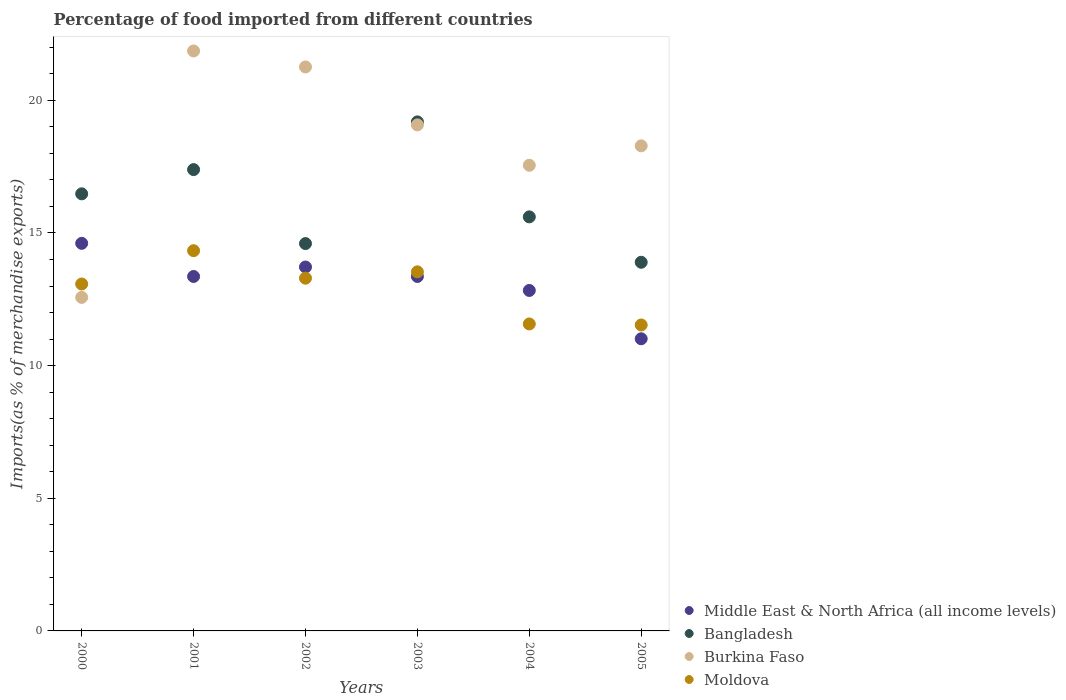What is the percentage of imports to different countries in Bangladesh in 2005?
Make the answer very short. 13.9. Across all years, what is the maximum percentage of imports to different countries in Burkina Faso?
Make the answer very short. 21.86. Across all years, what is the minimum percentage of imports to different countries in Bangladesh?
Ensure brevity in your answer.  13.9. In which year was the percentage of imports to different countries in Bangladesh minimum?
Ensure brevity in your answer.  2005. What is the total percentage of imports to different countries in Bangladesh in the graph?
Keep it short and to the point. 97.16. What is the difference between the percentage of imports to different countries in Moldova in 2000 and that in 2004?
Provide a short and direct response. 1.51. What is the difference between the percentage of imports to different countries in Bangladesh in 2004 and the percentage of imports to different countries in Moldova in 2003?
Provide a short and direct response. 2.07. What is the average percentage of imports to different countries in Middle East & North Africa (all income levels) per year?
Make the answer very short. 13.15. In the year 2004, what is the difference between the percentage of imports to different countries in Moldova and percentage of imports to different countries in Burkina Faso?
Make the answer very short. -5.98. In how many years, is the percentage of imports to different countries in Moldova greater than 12 %?
Provide a succinct answer. 4. What is the ratio of the percentage of imports to different countries in Burkina Faso in 2001 to that in 2003?
Make the answer very short. 1.15. Is the percentage of imports to different countries in Middle East & North Africa (all income levels) in 2003 less than that in 2004?
Keep it short and to the point. No. Is the difference between the percentage of imports to different countries in Moldova in 2004 and 2005 greater than the difference between the percentage of imports to different countries in Burkina Faso in 2004 and 2005?
Make the answer very short. Yes. What is the difference between the highest and the second highest percentage of imports to different countries in Moldova?
Offer a terse response. 0.8. What is the difference between the highest and the lowest percentage of imports to different countries in Middle East & North Africa (all income levels)?
Ensure brevity in your answer.  3.6. In how many years, is the percentage of imports to different countries in Moldova greater than the average percentage of imports to different countries in Moldova taken over all years?
Provide a succinct answer. 4. Does the percentage of imports to different countries in Middle East & North Africa (all income levels) monotonically increase over the years?
Provide a short and direct response. No. Is the percentage of imports to different countries in Middle East & North Africa (all income levels) strictly greater than the percentage of imports to different countries in Moldova over the years?
Make the answer very short. No. How many years are there in the graph?
Ensure brevity in your answer.  6. Are the values on the major ticks of Y-axis written in scientific E-notation?
Offer a terse response. No. Does the graph contain any zero values?
Provide a short and direct response. No. Where does the legend appear in the graph?
Offer a terse response. Bottom right. How many legend labels are there?
Your response must be concise. 4. How are the legend labels stacked?
Ensure brevity in your answer.  Vertical. What is the title of the graph?
Offer a terse response. Percentage of food imported from different countries. What is the label or title of the Y-axis?
Give a very brief answer. Imports(as % of merchandise exports). What is the Imports(as % of merchandise exports) of Middle East & North Africa (all income levels) in 2000?
Make the answer very short. 14.61. What is the Imports(as % of merchandise exports) of Bangladesh in 2000?
Make the answer very short. 16.48. What is the Imports(as % of merchandise exports) of Burkina Faso in 2000?
Give a very brief answer. 12.57. What is the Imports(as % of merchandise exports) in Moldova in 2000?
Give a very brief answer. 13.08. What is the Imports(as % of merchandise exports) of Middle East & North Africa (all income levels) in 2001?
Your answer should be very brief. 13.36. What is the Imports(as % of merchandise exports) in Bangladesh in 2001?
Your response must be concise. 17.39. What is the Imports(as % of merchandise exports) of Burkina Faso in 2001?
Offer a very short reply. 21.86. What is the Imports(as % of merchandise exports) in Moldova in 2001?
Offer a terse response. 14.33. What is the Imports(as % of merchandise exports) in Middle East & North Africa (all income levels) in 2002?
Your answer should be very brief. 13.72. What is the Imports(as % of merchandise exports) in Bangladesh in 2002?
Keep it short and to the point. 14.6. What is the Imports(as % of merchandise exports) in Burkina Faso in 2002?
Offer a very short reply. 21.26. What is the Imports(as % of merchandise exports) in Moldova in 2002?
Offer a terse response. 13.3. What is the Imports(as % of merchandise exports) of Middle East & North Africa (all income levels) in 2003?
Make the answer very short. 13.36. What is the Imports(as % of merchandise exports) of Bangladesh in 2003?
Your answer should be compact. 19.19. What is the Imports(as % of merchandise exports) of Burkina Faso in 2003?
Keep it short and to the point. 19.07. What is the Imports(as % of merchandise exports) in Moldova in 2003?
Your answer should be very brief. 13.54. What is the Imports(as % of merchandise exports) in Middle East & North Africa (all income levels) in 2004?
Provide a short and direct response. 12.83. What is the Imports(as % of merchandise exports) of Bangladesh in 2004?
Provide a short and direct response. 15.61. What is the Imports(as % of merchandise exports) of Burkina Faso in 2004?
Offer a very short reply. 17.55. What is the Imports(as % of merchandise exports) of Moldova in 2004?
Keep it short and to the point. 11.57. What is the Imports(as % of merchandise exports) in Middle East & North Africa (all income levels) in 2005?
Keep it short and to the point. 11.01. What is the Imports(as % of merchandise exports) of Bangladesh in 2005?
Offer a very short reply. 13.9. What is the Imports(as % of merchandise exports) of Burkina Faso in 2005?
Make the answer very short. 18.28. What is the Imports(as % of merchandise exports) in Moldova in 2005?
Keep it short and to the point. 11.53. Across all years, what is the maximum Imports(as % of merchandise exports) in Middle East & North Africa (all income levels)?
Make the answer very short. 14.61. Across all years, what is the maximum Imports(as % of merchandise exports) in Bangladesh?
Offer a terse response. 19.19. Across all years, what is the maximum Imports(as % of merchandise exports) in Burkina Faso?
Provide a succinct answer. 21.86. Across all years, what is the maximum Imports(as % of merchandise exports) of Moldova?
Provide a succinct answer. 14.33. Across all years, what is the minimum Imports(as % of merchandise exports) of Middle East & North Africa (all income levels)?
Offer a terse response. 11.01. Across all years, what is the minimum Imports(as % of merchandise exports) in Bangladesh?
Offer a very short reply. 13.9. Across all years, what is the minimum Imports(as % of merchandise exports) in Burkina Faso?
Offer a very short reply. 12.57. Across all years, what is the minimum Imports(as % of merchandise exports) in Moldova?
Keep it short and to the point. 11.53. What is the total Imports(as % of merchandise exports) of Middle East & North Africa (all income levels) in the graph?
Offer a very short reply. 78.9. What is the total Imports(as % of merchandise exports) of Bangladesh in the graph?
Provide a short and direct response. 97.16. What is the total Imports(as % of merchandise exports) of Burkina Faso in the graph?
Give a very brief answer. 110.6. What is the total Imports(as % of merchandise exports) of Moldova in the graph?
Provide a short and direct response. 77.34. What is the difference between the Imports(as % of merchandise exports) of Middle East & North Africa (all income levels) in 2000 and that in 2001?
Provide a succinct answer. 1.25. What is the difference between the Imports(as % of merchandise exports) of Bangladesh in 2000 and that in 2001?
Keep it short and to the point. -0.91. What is the difference between the Imports(as % of merchandise exports) in Burkina Faso in 2000 and that in 2001?
Provide a succinct answer. -9.29. What is the difference between the Imports(as % of merchandise exports) in Moldova in 2000 and that in 2001?
Provide a short and direct response. -1.26. What is the difference between the Imports(as % of merchandise exports) of Middle East & North Africa (all income levels) in 2000 and that in 2002?
Ensure brevity in your answer.  0.89. What is the difference between the Imports(as % of merchandise exports) in Bangladesh in 2000 and that in 2002?
Offer a very short reply. 1.87. What is the difference between the Imports(as % of merchandise exports) in Burkina Faso in 2000 and that in 2002?
Your answer should be very brief. -8.69. What is the difference between the Imports(as % of merchandise exports) in Moldova in 2000 and that in 2002?
Give a very brief answer. -0.22. What is the difference between the Imports(as % of merchandise exports) of Middle East & North Africa (all income levels) in 2000 and that in 2003?
Offer a very short reply. 1.25. What is the difference between the Imports(as % of merchandise exports) in Bangladesh in 2000 and that in 2003?
Keep it short and to the point. -2.71. What is the difference between the Imports(as % of merchandise exports) in Burkina Faso in 2000 and that in 2003?
Your answer should be compact. -6.5. What is the difference between the Imports(as % of merchandise exports) in Moldova in 2000 and that in 2003?
Offer a terse response. -0.46. What is the difference between the Imports(as % of merchandise exports) of Middle East & North Africa (all income levels) in 2000 and that in 2004?
Provide a short and direct response. 1.78. What is the difference between the Imports(as % of merchandise exports) of Bangladesh in 2000 and that in 2004?
Offer a very short reply. 0.87. What is the difference between the Imports(as % of merchandise exports) in Burkina Faso in 2000 and that in 2004?
Provide a short and direct response. -4.98. What is the difference between the Imports(as % of merchandise exports) in Moldova in 2000 and that in 2004?
Provide a short and direct response. 1.51. What is the difference between the Imports(as % of merchandise exports) in Middle East & North Africa (all income levels) in 2000 and that in 2005?
Provide a succinct answer. 3.6. What is the difference between the Imports(as % of merchandise exports) in Bangladesh in 2000 and that in 2005?
Your answer should be very brief. 2.58. What is the difference between the Imports(as % of merchandise exports) in Burkina Faso in 2000 and that in 2005?
Make the answer very short. -5.71. What is the difference between the Imports(as % of merchandise exports) of Moldova in 2000 and that in 2005?
Offer a terse response. 1.54. What is the difference between the Imports(as % of merchandise exports) of Middle East & North Africa (all income levels) in 2001 and that in 2002?
Offer a very short reply. -0.36. What is the difference between the Imports(as % of merchandise exports) in Bangladesh in 2001 and that in 2002?
Give a very brief answer. 2.79. What is the difference between the Imports(as % of merchandise exports) of Burkina Faso in 2001 and that in 2002?
Offer a very short reply. 0.6. What is the difference between the Imports(as % of merchandise exports) of Moldova in 2001 and that in 2002?
Provide a succinct answer. 1.04. What is the difference between the Imports(as % of merchandise exports) of Middle East & North Africa (all income levels) in 2001 and that in 2003?
Make the answer very short. 0. What is the difference between the Imports(as % of merchandise exports) in Bangladesh in 2001 and that in 2003?
Offer a terse response. -1.8. What is the difference between the Imports(as % of merchandise exports) of Burkina Faso in 2001 and that in 2003?
Keep it short and to the point. 2.79. What is the difference between the Imports(as % of merchandise exports) of Moldova in 2001 and that in 2003?
Your answer should be compact. 0.8. What is the difference between the Imports(as % of merchandise exports) in Middle East & North Africa (all income levels) in 2001 and that in 2004?
Provide a succinct answer. 0.53. What is the difference between the Imports(as % of merchandise exports) in Bangladesh in 2001 and that in 2004?
Keep it short and to the point. 1.78. What is the difference between the Imports(as % of merchandise exports) of Burkina Faso in 2001 and that in 2004?
Keep it short and to the point. 4.31. What is the difference between the Imports(as % of merchandise exports) in Moldova in 2001 and that in 2004?
Ensure brevity in your answer.  2.76. What is the difference between the Imports(as % of merchandise exports) in Middle East & North Africa (all income levels) in 2001 and that in 2005?
Make the answer very short. 2.35. What is the difference between the Imports(as % of merchandise exports) in Bangladesh in 2001 and that in 2005?
Give a very brief answer. 3.49. What is the difference between the Imports(as % of merchandise exports) of Burkina Faso in 2001 and that in 2005?
Make the answer very short. 3.58. What is the difference between the Imports(as % of merchandise exports) of Moldova in 2001 and that in 2005?
Offer a terse response. 2.8. What is the difference between the Imports(as % of merchandise exports) in Middle East & North Africa (all income levels) in 2002 and that in 2003?
Offer a very short reply. 0.36. What is the difference between the Imports(as % of merchandise exports) of Bangladesh in 2002 and that in 2003?
Your answer should be compact. -4.59. What is the difference between the Imports(as % of merchandise exports) of Burkina Faso in 2002 and that in 2003?
Offer a very short reply. 2.18. What is the difference between the Imports(as % of merchandise exports) in Moldova in 2002 and that in 2003?
Give a very brief answer. -0.24. What is the difference between the Imports(as % of merchandise exports) in Middle East & North Africa (all income levels) in 2002 and that in 2004?
Offer a very short reply. 0.88. What is the difference between the Imports(as % of merchandise exports) in Bangladesh in 2002 and that in 2004?
Your answer should be compact. -1.01. What is the difference between the Imports(as % of merchandise exports) in Burkina Faso in 2002 and that in 2004?
Make the answer very short. 3.71. What is the difference between the Imports(as % of merchandise exports) of Moldova in 2002 and that in 2004?
Provide a succinct answer. 1.73. What is the difference between the Imports(as % of merchandise exports) in Middle East & North Africa (all income levels) in 2002 and that in 2005?
Your answer should be very brief. 2.7. What is the difference between the Imports(as % of merchandise exports) in Bangladesh in 2002 and that in 2005?
Ensure brevity in your answer.  0.7. What is the difference between the Imports(as % of merchandise exports) in Burkina Faso in 2002 and that in 2005?
Your response must be concise. 2.97. What is the difference between the Imports(as % of merchandise exports) in Moldova in 2002 and that in 2005?
Give a very brief answer. 1.76. What is the difference between the Imports(as % of merchandise exports) in Middle East & North Africa (all income levels) in 2003 and that in 2004?
Offer a very short reply. 0.53. What is the difference between the Imports(as % of merchandise exports) of Bangladesh in 2003 and that in 2004?
Your answer should be compact. 3.58. What is the difference between the Imports(as % of merchandise exports) in Burkina Faso in 2003 and that in 2004?
Your answer should be very brief. 1.52. What is the difference between the Imports(as % of merchandise exports) of Moldova in 2003 and that in 2004?
Your response must be concise. 1.96. What is the difference between the Imports(as % of merchandise exports) in Middle East & North Africa (all income levels) in 2003 and that in 2005?
Offer a terse response. 2.35. What is the difference between the Imports(as % of merchandise exports) in Bangladesh in 2003 and that in 2005?
Make the answer very short. 5.29. What is the difference between the Imports(as % of merchandise exports) of Burkina Faso in 2003 and that in 2005?
Offer a terse response. 0.79. What is the difference between the Imports(as % of merchandise exports) of Moldova in 2003 and that in 2005?
Provide a short and direct response. 2. What is the difference between the Imports(as % of merchandise exports) in Middle East & North Africa (all income levels) in 2004 and that in 2005?
Provide a short and direct response. 1.82. What is the difference between the Imports(as % of merchandise exports) of Bangladesh in 2004 and that in 2005?
Offer a terse response. 1.71. What is the difference between the Imports(as % of merchandise exports) of Burkina Faso in 2004 and that in 2005?
Ensure brevity in your answer.  -0.73. What is the difference between the Imports(as % of merchandise exports) of Moldova in 2004 and that in 2005?
Your response must be concise. 0.04. What is the difference between the Imports(as % of merchandise exports) of Middle East & North Africa (all income levels) in 2000 and the Imports(as % of merchandise exports) of Bangladesh in 2001?
Your response must be concise. -2.78. What is the difference between the Imports(as % of merchandise exports) of Middle East & North Africa (all income levels) in 2000 and the Imports(as % of merchandise exports) of Burkina Faso in 2001?
Your response must be concise. -7.25. What is the difference between the Imports(as % of merchandise exports) of Middle East & North Africa (all income levels) in 2000 and the Imports(as % of merchandise exports) of Moldova in 2001?
Ensure brevity in your answer.  0.28. What is the difference between the Imports(as % of merchandise exports) in Bangladesh in 2000 and the Imports(as % of merchandise exports) in Burkina Faso in 2001?
Your response must be concise. -5.39. What is the difference between the Imports(as % of merchandise exports) of Bangladesh in 2000 and the Imports(as % of merchandise exports) of Moldova in 2001?
Make the answer very short. 2.14. What is the difference between the Imports(as % of merchandise exports) of Burkina Faso in 2000 and the Imports(as % of merchandise exports) of Moldova in 2001?
Provide a short and direct response. -1.76. What is the difference between the Imports(as % of merchandise exports) of Middle East & North Africa (all income levels) in 2000 and the Imports(as % of merchandise exports) of Bangladesh in 2002?
Offer a very short reply. 0.01. What is the difference between the Imports(as % of merchandise exports) of Middle East & North Africa (all income levels) in 2000 and the Imports(as % of merchandise exports) of Burkina Faso in 2002?
Offer a very short reply. -6.65. What is the difference between the Imports(as % of merchandise exports) in Middle East & North Africa (all income levels) in 2000 and the Imports(as % of merchandise exports) in Moldova in 2002?
Ensure brevity in your answer.  1.31. What is the difference between the Imports(as % of merchandise exports) in Bangladesh in 2000 and the Imports(as % of merchandise exports) in Burkina Faso in 2002?
Your answer should be compact. -4.78. What is the difference between the Imports(as % of merchandise exports) of Bangladesh in 2000 and the Imports(as % of merchandise exports) of Moldova in 2002?
Your answer should be very brief. 3.18. What is the difference between the Imports(as % of merchandise exports) in Burkina Faso in 2000 and the Imports(as % of merchandise exports) in Moldova in 2002?
Provide a succinct answer. -0.72. What is the difference between the Imports(as % of merchandise exports) in Middle East & North Africa (all income levels) in 2000 and the Imports(as % of merchandise exports) in Bangladesh in 2003?
Provide a short and direct response. -4.58. What is the difference between the Imports(as % of merchandise exports) in Middle East & North Africa (all income levels) in 2000 and the Imports(as % of merchandise exports) in Burkina Faso in 2003?
Provide a succinct answer. -4.46. What is the difference between the Imports(as % of merchandise exports) of Middle East & North Africa (all income levels) in 2000 and the Imports(as % of merchandise exports) of Moldova in 2003?
Your answer should be compact. 1.07. What is the difference between the Imports(as % of merchandise exports) of Bangladesh in 2000 and the Imports(as % of merchandise exports) of Burkina Faso in 2003?
Your answer should be very brief. -2.6. What is the difference between the Imports(as % of merchandise exports) in Bangladesh in 2000 and the Imports(as % of merchandise exports) in Moldova in 2003?
Your answer should be compact. 2.94. What is the difference between the Imports(as % of merchandise exports) of Burkina Faso in 2000 and the Imports(as % of merchandise exports) of Moldova in 2003?
Make the answer very short. -0.96. What is the difference between the Imports(as % of merchandise exports) in Middle East & North Africa (all income levels) in 2000 and the Imports(as % of merchandise exports) in Bangladesh in 2004?
Keep it short and to the point. -1. What is the difference between the Imports(as % of merchandise exports) in Middle East & North Africa (all income levels) in 2000 and the Imports(as % of merchandise exports) in Burkina Faso in 2004?
Make the answer very short. -2.94. What is the difference between the Imports(as % of merchandise exports) in Middle East & North Africa (all income levels) in 2000 and the Imports(as % of merchandise exports) in Moldova in 2004?
Give a very brief answer. 3.04. What is the difference between the Imports(as % of merchandise exports) in Bangladesh in 2000 and the Imports(as % of merchandise exports) in Burkina Faso in 2004?
Your answer should be very brief. -1.08. What is the difference between the Imports(as % of merchandise exports) of Bangladesh in 2000 and the Imports(as % of merchandise exports) of Moldova in 2004?
Offer a very short reply. 4.91. What is the difference between the Imports(as % of merchandise exports) in Burkina Faso in 2000 and the Imports(as % of merchandise exports) in Moldova in 2004?
Your answer should be very brief. 1. What is the difference between the Imports(as % of merchandise exports) of Middle East & North Africa (all income levels) in 2000 and the Imports(as % of merchandise exports) of Bangladesh in 2005?
Offer a terse response. 0.71. What is the difference between the Imports(as % of merchandise exports) in Middle East & North Africa (all income levels) in 2000 and the Imports(as % of merchandise exports) in Burkina Faso in 2005?
Keep it short and to the point. -3.67. What is the difference between the Imports(as % of merchandise exports) of Middle East & North Africa (all income levels) in 2000 and the Imports(as % of merchandise exports) of Moldova in 2005?
Your answer should be very brief. 3.08. What is the difference between the Imports(as % of merchandise exports) in Bangladesh in 2000 and the Imports(as % of merchandise exports) in Burkina Faso in 2005?
Offer a very short reply. -1.81. What is the difference between the Imports(as % of merchandise exports) in Bangladesh in 2000 and the Imports(as % of merchandise exports) in Moldova in 2005?
Your answer should be compact. 4.94. What is the difference between the Imports(as % of merchandise exports) in Burkina Faso in 2000 and the Imports(as % of merchandise exports) in Moldova in 2005?
Provide a succinct answer. 1.04. What is the difference between the Imports(as % of merchandise exports) of Middle East & North Africa (all income levels) in 2001 and the Imports(as % of merchandise exports) of Bangladesh in 2002?
Ensure brevity in your answer.  -1.24. What is the difference between the Imports(as % of merchandise exports) of Middle East & North Africa (all income levels) in 2001 and the Imports(as % of merchandise exports) of Burkina Faso in 2002?
Ensure brevity in your answer.  -7.9. What is the difference between the Imports(as % of merchandise exports) in Middle East & North Africa (all income levels) in 2001 and the Imports(as % of merchandise exports) in Moldova in 2002?
Make the answer very short. 0.06. What is the difference between the Imports(as % of merchandise exports) in Bangladesh in 2001 and the Imports(as % of merchandise exports) in Burkina Faso in 2002?
Your answer should be very brief. -3.87. What is the difference between the Imports(as % of merchandise exports) in Bangladesh in 2001 and the Imports(as % of merchandise exports) in Moldova in 2002?
Offer a very short reply. 4.09. What is the difference between the Imports(as % of merchandise exports) of Burkina Faso in 2001 and the Imports(as % of merchandise exports) of Moldova in 2002?
Ensure brevity in your answer.  8.56. What is the difference between the Imports(as % of merchandise exports) of Middle East & North Africa (all income levels) in 2001 and the Imports(as % of merchandise exports) of Bangladesh in 2003?
Your answer should be very brief. -5.83. What is the difference between the Imports(as % of merchandise exports) of Middle East & North Africa (all income levels) in 2001 and the Imports(as % of merchandise exports) of Burkina Faso in 2003?
Keep it short and to the point. -5.71. What is the difference between the Imports(as % of merchandise exports) of Middle East & North Africa (all income levels) in 2001 and the Imports(as % of merchandise exports) of Moldova in 2003?
Offer a very short reply. -0.17. What is the difference between the Imports(as % of merchandise exports) in Bangladesh in 2001 and the Imports(as % of merchandise exports) in Burkina Faso in 2003?
Keep it short and to the point. -1.69. What is the difference between the Imports(as % of merchandise exports) of Bangladesh in 2001 and the Imports(as % of merchandise exports) of Moldova in 2003?
Ensure brevity in your answer.  3.85. What is the difference between the Imports(as % of merchandise exports) of Burkina Faso in 2001 and the Imports(as % of merchandise exports) of Moldova in 2003?
Make the answer very short. 8.33. What is the difference between the Imports(as % of merchandise exports) in Middle East & North Africa (all income levels) in 2001 and the Imports(as % of merchandise exports) in Bangladesh in 2004?
Make the answer very short. -2.25. What is the difference between the Imports(as % of merchandise exports) of Middle East & North Africa (all income levels) in 2001 and the Imports(as % of merchandise exports) of Burkina Faso in 2004?
Ensure brevity in your answer.  -4.19. What is the difference between the Imports(as % of merchandise exports) in Middle East & North Africa (all income levels) in 2001 and the Imports(as % of merchandise exports) in Moldova in 2004?
Make the answer very short. 1.79. What is the difference between the Imports(as % of merchandise exports) of Bangladesh in 2001 and the Imports(as % of merchandise exports) of Burkina Faso in 2004?
Your answer should be very brief. -0.16. What is the difference between the Imports(as % of merchandise exports) of Bangladesh in 2001 and the Imports(as % of merchandise exports) of Moldova in 2004?
Provide a short and direct response. 5.82. What is the difference between the Imports(as % of merchandise exports) of Burkina Faso in 2001 and the Imports(as % of merchandise exports) of Moldova in 2004?
Keep it short and to the point. 10.29. What is the difference between the Imports(as % of merchandise exports) in Middle East & North Africa (all income levels) in 2001 and the Imports(as % of merchandise exports) in Bangladesh in 2005?
Offer a very short reply. -0.54. What is the difference between the Imports(as % of merchandise exports) in Middle East & North Africa (all income levels) in 2001 and the Imports(as % of merchandise exports) in Burkina Faso in 2005?
Offer a terse response. -4.92. What is the difference between the Imports(as % of merchandise exports) of Middle East & North Africa (all income levels) in 2001 and the Imports(as % of merchandise exports) of Moldova in 2005?
Keep it short and to the point. 1.83. What is the difference between the Imports(as % of merchandise exports) in Bangladesh in 2001 and the Imports(as % of merchandise exports) in Burkina Faso in 2005?
Your answer should be compact. -0.9. What is the difference between the Imports(as % of merchandise exports) in Bangladesh in 2001 and the Imports(as % of merchandise exports) in Moldova in 2005?
Give a very brief answer. 5.86. What is the difference between the Imports(as % of merchandise exports) of Burkina Faso in 2001 and the Imports(as % of merchandise exports) of Moldova in 2005?
Offer a very short reply. 10.33. What is the difference between the Imports(as % of merchandise exports) of Middle East & North Africa (all income levels) in 2002 and the Imports(as % of merchandise exports) of Bangladesh in 2003?
Ensure brevity in your answer.  -5.47. What is the difference between the Imports(as % of merchandise exports) in Middle East & North Africa (all income levels) in 2002 and the Imports(as % of merchandise exports) in Burkina Faso in 2003?
Your answer should be very brief. -5.36. What is the difference between the Imports(as % of merchandise exports) in Middle East & North Africa (all income levels) in 2002 and the Imports(as % of merchandise exports) in Moldova in 2003?
Your response must be concise. 0.18. What is the difference between the Imports(as % of merchandise exports) in Bangladesh in 2002 and the Imports(as % of merchandise exports) in Burkina Faso in 2003?
Your answer should be compact. -4.47. What is the difference between the Imports(as % of merchandise exports) of Bangladesh in 2002 and the Imports(as % of merchandise exports) of Moldova in 2003?
Offer a terse response. 1.07. What is the difference between the Imports(as % of merchandise exports) of Burkina Faso in 2002 and the Imports(as % of merchandise exports) of Moldova in 2003?
Provide a short and direct response. 7.72. What is the difference between the Imports(as % of merchandise exports) of Middle East & North Africa (all income levels) in 2002 and the Imports(as % of merchandise exports) of Bangladesh in 2004?
Ensure brevity in your answer.  -1.89. What is the difference between the Imports(as % of merchandise exports) in Middle East & North Africa (all income levels) in 2002 and the Imports(as % of merchandise exports) in Burkina Faso in 2004?
Ensure brevity in your answer.  -3.84. What is the difference between the Imports(as % of merchandise exports) of Middle East & North Africa (all income levels) in 2002 and the Imports(as % of merchandise exports) of Moldova in 2004?
Make the answer very short. 2.15. What is the difference between the Imports(as % of merchandise exports) in Bangladesh in 2002 and the Imports(as % of merchandise exports) in Burkina Faso in 2004?
Keep it short and to the point. -2.95. What is the difference between the Imports(as % of merchandise exports) in Bangladesh in 2002 and the Imports(as % of merchandise exports) in Moldova in 2004?
Ensure brevity in your answer.  3.03. What is the difference between the Imports(as % of merchandise exports) of Burkina Faso in 2002 and the Imports(as % of merchandise exports) of Moldova in 2004?
Provide a succinct answer. 9.69. What is the difference between the Imports(as % of merchandise exports) of Middle East & North Africa (all income levels) in 2002 and the Imports(as % of merchandise exports) of Bangladesh in 2005?
Your answer should be compact. -0.18. What is the difference between the Imports(as % of merchandise exports) of Middle East & North Africa (all income levels) in 2002 and the Imports(as % of merchandise exports) of Burkina Faso in 2005?
Your response must be concise. -4.57. What is the difference between the Imports(as % of merchandise exports) of Middle East & North Africa (all income levels) in 2002 and the Imports(as % of merchandise exports) of Moldova in 2005?
Give a very brief answer. 2.18. What is the difference between the Imports(as % of merchandise exports) in Bangladesh in 2002 and the Imports(as % of merchandise exports) in Burkina Faso in 2005?
Keep it short and to the point. -3.68. What is the difference between the Imports(as % of merchandise exports) in Bangladesh in 2002 and the Imports(as % of merchandise exports) in Moldova in 2005?
Provide a short and direct response. 3.07. What is the difference between the Imports(as % of merchandise exports) in Burkina Faso in 2002 and the Imports(as % of merchandise exports) in Moldova in 2005?
Ensure brevity in your answer.  9.73. What is the difference between the Imports(as % of merchandise exports) in Middle East & North Africa (all income levels) in 2003 and the Imports(as % of merchandise exports) in Bangladesh in 2004?
Offer a terse response. -2.25. What is the difference between the Imports(as % of merchandise exports) in Middle East & North Africa (all income levels) in 2003 and the Imports(as % of merchandise exports) in Burkina Faso in 2004?
Provide a succinct answer. -4.19. What is the difference between the Imports(as % of merchandise exports) of Middle East & North Africa (all income levels) in 2003 and the Imports(as % of merchandise exports) of Moldova in 2004?
Your answer should be compact. 1.79. What is the difference between the Imports(as % of merchandise exports) in Bangladesh in 2003 and the Imports(as % of merchandise exports) in Burkina Faso in 2004?
Offer a very short reply. 1.64. What is the difference between the Imports(as % of merchandise exports) in Bangladesh in 2003 and the Imports(as % of merchandise exports) in Moldova in 2004?
Give a very brief answer. 7.62. What is the difference between the Imports(as % of merchandise exports) in Burkina Faso in 2003 and the Imports(as % of merchandise exports) in Moldova in 2004?
Your response must be concise. 7.5. What is the difference between the Imports(as % of merchandise exports) in Middle East & North Africa (all income levels) in 2003 and the Imports(as % of merchandise exports) in Bangladesh in 2005?
Make the answer very short. -0.54. What is the difference between the Imports(as % of merchandise exports) of Middle East & North Africa (all income levels) in 2003 and the Imports(as % of merchandise exports) of Burkina Faso in 2005?
Your answer should be compact. -4.92. What is the difference between the Imports(as % of merchandise exports) in Middle East & North Africa (all income levels) in 2003 and the Imports(as % of merchandise exports) in Moldova in 2005?
Your answer should be compact. 1.83. What is the difference between the Imports(as % of merchandise exports) in Bangladesh in 2003 and the Imports(as % of merchandise exports) in Burkina Faso in 2005?
Your response must be concise. 0.9. What is the difference between the Imports(as % of merchandise exports) of Bangladesh in 2003 and the Imports(as % of merchandise exports) of Moldova in 2005?
Make the answer very short. 7.65. What is the difference between the Imports(as % of merchandise exports) in Burkina Faso in 2003 and the Imports(as % of merchandise exports) in Moldova in 2005?
Offer a very short reply. 7.54. What is the difference between the Imports(as % of merchandise exports) in Middle East & North Africa (all income levels) in 2004 and the Imports(as % of merchandise exports) in Bangladesh in 2005?
Ensure brevity in your answer.  -1.06. What is the difference between the Imports(as % of merchandise exports) in Middle East & North Africa (all income levels) in 2004 and the Imports(as % of merchandise exports) in Burkina Faso in 2005?
Offer a very short reply. -5.45. What is the difference between the Imports(as % of merchandise exports) in Middle East & North Africa (all income levels) in 2004 and the Imports(as % of merchandise exports) in Moldova in 2005?
Your answer should be compact. 1.3. What is the difference between the Imports(as % of merchandise exports) of Bangladesh in 2004 and the Imports(as % of merchandise exports) of Burkina Faso in 2005?
Provide a succinct answer. -2.68. What is the difference between the Imports(as % of merchandise exports) in Bangladesh in 2004 and the Imports(as % of merchandise exports) in Moldova in 2005?
Give a very brief answer. 4.07. What is the difference between the Imports(as % of merchandise exports) of Burkina Faso in 2004 and the Imports(as % of merchandise exports) of Moldova in 2005?
Provide a short and direct response. 6.02. What is the average Imports(as % of merchandise exports) in Middle East & North Africa (all income levels) per year?
Make the answer very short. 13.15. What is the average Imports(as % of merchandise exports) in Bangladesh per year?
Keep it short and to the point. 16.19. What is the average Imports(as % of merchandise exports) in Burkina Faso per year?
Your response must be concise. 18.43. What is the average Imports(as % of merchandise exports) of Moldova per year?
Provide a short and direct response. 12.89. In the year 2000, what is the difference between the Imports(as % of merchandise exports) in Middle East & North Africa (all income levels) and Imports(as % of merchandise exports) in Bangladesh?
Offer a terse response. -1.87. In the year 2000, what is the difference between the Imports(as % of merchandise exports) in Middle East & North Africa (all income levels) and Imports(as % of merchandise exports) in Burkina Faso?
Provide a short and direct response. 2.04. In the year 2000, what is the difference between the Imports(as % of merchandise exports) of Middle East & North Africa (all income levels) and Imports(as % of merchandise exports) of Moldova?
Offer a very short reply. 1.53. In the year 2000, what is the difference between the Imports(as % of merchandise exports) of Bangladesh and Imports(as % of merchandise exports) of Burkina Faso?
Your answer should be compact. 3.9. In the year 2000, what is the difference between the Imports(as % of merchandise exports) in Bangladesh and Imports(as % of merchandise exports) in Moldova?
Ensure brevity in your answer.  3.4. In the year 2000, what is the difference between the Imports(as % of merchandise exports) in Burkina Faso and Imports(as % of merchandise exports) in Moldova?
Your answer should be very brief. -0.5. In the year 2001, what is the difference between the Imports(as % of merchandise exports) of Middle East & North Africa (all income levels) and Imports(as % of merchandise exports) of Bangladesh?
Your answer should be very brief. -4.03. In the year 2001, what is the difference between the Imports(as % of merchandise exports) in Middle East & North Africa (all income levels) and Imports(as % of merchandise exports) in Burkina Faso?
Give a very brief answer. -8.5. In the year 2001, what is the difference between the Imports(as % of merchandise exports) in Middle East & North Africa (all income levels) and Imports(as % of merchandise exports) in Moldova?
Offer a terse response. -0.97. In the year 2001, what is the difference between the Imports(as % of merchandise exports) of Bangladesh and Imports(as % of merchandise exports) of Burkina Faso?
Provide a succinct answer. -4.47. In the year 2001, what is the difference between the Imports(as % of merchandise exports) of Bangladesh and Imports(as % of merchandise exports) of Moldova?
Your response must be concise. 3.06. In the year 2001, what is the difference between the Imports(as % of merchandise exports) in Burkina Faso and Imports(as % of merchandise exports) in Moldova?
Keep it short and to the point. 7.53. In the year 2002, what is the difference between the Imports(as % of merchandise exports) of Middle East & North Africa (all income levels) and Imports(as % of merchandise exports) of Bangladesh?
Make the answer very short. -0.88. In the year 2002, what is the difference between the Imports(as % of merchandise exports) of Middle East & North Africa (all income levels) and Imports(as % of merchandise exports) of Burkina Faso?
Offer a very short reply. -7.54. In the year 2002, what is the difference between the Imports(as % of merchandise exports) in Middle East & North Africa (all income levels) and Imports(as % of merchandise exports) in Moldova?
Provide a succinct answer. 0.42. In the year 2002, what is the difference between the Imports(as % of merchandise exports) in Bangladesh and Imports(as % of merchandise exports) in Burkina Faso?
Ensure brevity in your answer.  -6.66. In the year 2002, what is the difference between the Imports(as % of merchandise exports) in Bangladesh and Imports(as % of merchandise exports) in Moldova?
Make the answer very short. 1.3. In the year 2002, what is the difference between the Imports(as % of merchandise exports) of Burkina Faso and Imports(as % of merchandise exports) of Moldova?
Keep it short and to the point. 7.96. In the year 2003, what is the difference between the Imports(as % of merchandise exports) of Middle East & North Africa (all income levels) and Imports(as % of merchandise exports) of Bangladesh?
Provide a succinct answer. -5.83. In the year 2003, what is the difference between the Imports(as % of merchandise exports) of Middle East & North Africa (all income levels) and Imports(as % of merchandise exports) of Burkina Faso?
Give a very brief answer. -5.71. In the year 2003, what is the difference between the Imports(as % of merchandise exports) in Middle East & North Africa (all income levels) and Imports(as % of merchandise exports) in Moldova?
Give a very brief answer. -0.17. In the year 2003, what is the difference between the Imports(as % of merchandise exports) in Bangladesh and Imports(as % of merchandise exports) in Burkina Faso?
Keep it short and to the point. 0.11. In the year 2003, what is the difference between the Imports(as % of merchandise exports) of Bangladesh and Imports(as % of merchandise exports) of Moldova?
Offer a very short reply. 5.65. In the year 2003, what is the difference between the Imports(as % of merchandise exports) in Burkina Faso and Imports(as % of merchandise exports) in Moldova?
Keep it short and to the point. 5.54. In the year 2004, what is the difference between the Imports(as % of merchandise exports) in Middle East & North Africa (all income levels) and Imports(as % of merchandise exports) in Bangladesh?
Give a very brief answer. -2.77. In the year 2004, what is the difference between the Imports(as % of merchandise exports) in Middle East & North Africa (all income levels) and Imports(as % of merchandise exports) in Burkina Faso?
Keep it short and to the point. -4.72. In the year 2004, what is the difference between the Imports(as % of merchandise exports) of Middle East & North Africa (all income levels) and Imports(as % of merchandise exports) of Moldova?
Make the answer very short. 1.26. In the year 2004, what is the difference between the Imports(as % of merchandise exports) in Bangladesh and Imports(as % of merchandise exports) in Burkina Faso?
Offer a terse response. -1.95. In the year 2004, what is the difference between the Imports(as % of merchandise exports) of Bangladesh and Imports(as % of merchandise exports) of Moldova?
Provide a short and direct response. 4.04. In the year 2004, what is the difference between the Imports(as % of merchandise exports) in Burkina Faso and Imports(as % of merchandise exports) in Moldova?
Provide a succinct answer. 5.98. In the year 2005, what is the difference between the Imports(as % of merchandise exports) of Middle East & North Africa (all income levels) and Imports(as % of merchandise exports) of Bangladesh?
Ensure brevity in your answer.  -2.88. In the year 2005, what is the difference between the Imports(as % of merchandise exports) of Middle East & North Africa (all income levels) and Imports(as % of merchandise exports) of Burkina Faso?
Provide a short and direct response. -7.27. In the year 2005, what is the difference between the Imports(as % of merchandise exports) of Middle East & North Africa (all income levels) and Imports(as % of merchandise exports) of Moldova?
Your response must be concise. -0.52. In the year 2005, what is the difference between the Imports(as % of merchandise exports) in Bangladesh and Imports(as % of merchandise exports) in Burkina Faso?
Provide a succinct answer. -4.39. In the year 2005, what is the difference between the Imports(as % of merchandise exports) in Bangladesh and Imports(as % of merchandise exports) in Moldova?
Ensure brevity in your answer.  2.36. In the year 2005, what is the difference between the Imports(as % of merchandise exports) of Burkina Faso and Imports(as % of merchandise exports) of Moldova?
Give a very brief answer. 6.75. What is the ratio of the Imports(as % of merchandise exports) in Middle East & North Africa (all income levels) in 2000 to that in 2001?
Make the answer very short. 1.09. What is the ratio of the Imports(as % of merchandise exports) in Bangladesh in 2000 to that in 2001?
Keep it short and to the point. 0.95. What is the ratio of the Imports(as % of merchandise exports) in Burkina Faso in 2000 to that in 2001?
Ensure brevity in your answer.  0.58. What is the ratio of the Imports(as % of merchandise exports) of Moldova in 2000 to that in 2001?
Offer a terse response. 0.91. What is the ratio of the Imports(as % of merchandise exports) in Middle East & North Africa (all income levels) in 2000 to that in 2002?
Offer a terse response. 1.07. What is the ratio of the Imports(as % of merchandise exports) in Bangladesh in 2000 to that in 2002?
Give a very brief answer. 1.13. What is the ratio of the Imports(as % of merchandise exports) of Burkina Faso in 2000 to that in 2002?
Offer a terse response. 0.59. What is the ratio of the Imports(as % of merchandise exports) of Moldova in 2000 to that in 2002?
Offer a terse response. 0.98. What is the ratio of the Imports(as % of merchandise exports) in Middle East & North Africa (all income levels) in 2000 to that in 2003?
Give a very brief answer. 1.09. What is the ratio of the Imports(as % of merchandise exports) in Bangladesh in 2000 to that in 2003?
Keep it short and to the point. 0.86. What is the ratio of the Imports(as % of merchandise exports) of Burkina Faso in 2000 to that in 2003?
Provide a short and direct response. 0.66. What is the ratio of the Imports(as % of merchandise exports) of Moldova in 2000 to that in 2003?
Provide a short and direct response. 0.97. What is the ratio of the Imports(as % of merchandise exports) of Middle East & North Africa (all income levels) in 2000 to that in 2004?
Offer a terse response. 1.14. What is the ratio of the Imports(as % of merchandise exports) of Bangladesh in 2000 to that in 2004?
Your response must be concise. 1.06. What is the ratio of the Imports(as % of merchandise exports) in Burkina Faso in 2000 to that in 2004?
Your response must be concise. 0.72. What is the ratio of the Imports(as % of merchandise exports) in Moldova in 2000 to that in 2004?
Provide a succinct answer. 1.13. What is the ratio of the Imports(as % of merchandise exports) in Middle East & North Africa (all income levels) in 2000 to that in 2005?
Keep it short and to the point. 1.33. What is the ratio of the Imports(as % of merchandise exports) of Bangladesh in 2000 to that in 2005?
Your answer should be compact. 1.19. What is the ratio of the Imports(as % of merchandise exports) in Burkina Faso in 2000 to that in 2005?
Provide a short and direct response. 0.69. What is the ratio of the Imports(as % of merchandise exports) in Moldova in 2000 to that in 2005?
Your answer should be very brief. 1.13. What is the ratio of the Imports(as % of merchandise exports) of Middle East & North Africa (all income levels) in 2001 to that in 2002?
Keep it short and to the point. 0.97. What is the ratio of the Imports(as % of merchandise exports) of Bangladesh in 2001 to that in 2002?
Make the answer very short. 1.19. What is the ratio of the Imports(as % of merchandise exports) of Burkina Faso in 2001 to that in 2002?
Offer a terse response. 1.03. What is the ratio of the Imports(as % of merchandise exports) of Moldova in 2001 to that in 2002?
Your response must be concise. 1.08. What is the ratio of the Imports(as % of merchandise exports) of Bangladesh in 2001 to that in 2003?
Your response must be concise. 0.91. What is the ratio of the Imports(as % of merchandise exports) of Burkina Faso in 2001 to that in 2003?
Provide a short and direct response. 1.15. What is the ratio of the Imports(as % of merchandise exports) of Moldova in 2001 to that in 2003?
Provide a short and direct response. 1.06. What is the ratio of the Imports(as % of merchandise exports) of Middle East & North Africa (all income levels) in 2001 to that in 2004?
Your response must be concise. 1.04. What is the ratio of the Imports(as % of merchandise exports) of Bangladesh in 2001 to that in 2004?
Ensure brevity in your answer.  1.11. What is the ratio of the Imports(as % of merchandise exports) in Burkina Faso in 2001 to that in 2004?
Keep it short and to the point. 1.25. What is the ratio of the Imports(as % of merchandise exports) in Moldova in 2001 to that in 2004?
Offer a very short reply. 1.24. What is the ratio of the Imports(as % of merchandise exports) in Middle East & North Africa (all income levels) in 2001 to that in 2005?
Provide a short and direct response. 1.21. What is the ratio of the Imports(as % of merchandise exports) in Bangladesh in 2001 to that in 2005?
Ensure brevity in your answer.  1.25. What is the ratio of the Imports(as % of merchandise exports) of Burkina Faso in 2001 to that in 2005?
Give a very brief answer. 1.2. What is the ratio of the Imports(as % of merchandise exports) of Moldova in 2001 to that in 2005?
Keep it short and to the point. 1.24. What is the ratio of the Imports(as % of merchandise exports) of Middle East & North Africa (all income levels) in 2002 to that in 2003?
Make the answer very short. 1.03. What is the ratio of the Imports(as % of merchandise exports) of Bangladesh in 2002 to that in 2003?
Make the answer very short. 0.76. What is the ratio of the Imports(as % of merchandise exports) in Burkina Faso in 2002 to that in 2003?
Ensure brevity in your answer.  1.11. What is the ratio of the Imports(as % of merchandise exports) of Moldova in 2002 to that in 2003?
Offer a very short reply. 0.98. What is the ratio of the Imports(as % of merchandise exports) of Middle East & North Africa (all income levels) in 2002 to that in 2004?
Keep it short and to the point. 1.07. What is the ratio of the Imports(as % of merchandise exports) in Bangladesh in 2002 to that in 2004?
Your answer should be compact. 0.94. What is the ratio of the Imports(as % of merchandise exports) of Burkina Faso in 2002 to that in 2004?
Your answer should be very brief. 1.21. What is the ratio of the Imports(as % of merchandise exports) of Moldova in 2002 to that in 2004?
Make the answer very short. 1.15. What is the ratio of the Imports(as % of merchandise exports) of Middle East & North Africa (all income levels) in 2002 to that in 2005?
Provide a succinct answer. 1.25. What is the ratio of the Imports(as % of merchandise exports) in Bangladesh in 2002 to that in 2005?
Provide a short and direct response. 1.05. What is the ratio of the Imports(as % of merchandise exports) of Burkina Faso in 2002 to that in 2005?
Provide a succinct answer. 1.16. What is the ratio of the Imports(as % of merchandise exports) in Moldova in 2002 to that in 2005?
Keep it short and to the point. 1.15. What is the ratio of the Imports(as % of merchandise exports) of Middle East & North Africa (all income levels) in 2003 to that in 2004?
Provide a succinct answer. 1.04. What is the ratio of the Imports(as % of merchandise exports) of Bangladesh in 2003 to that in 2004?
Offer a very short reply. 1.23. What is the ratio of the Imports(as % of merchandise exports) of Burkina Faso in 2003 to that in 2004?
Offer a very short reply. 1.09. What is the ratio of the Imports(as % of merchandise exports) of Moldova in 2003 to that in 2004?
Make the answer very short. 1.17. What is the ratio of the Imports(as % of merchandise exports) in Middle East & North Africa (all income levels) in 2003 to that in 2005?
Ensure brevity in your answer.  1.21. What is the ratio of the Imports(as % of merchandise exports) of Bangladesh in 2003 to that in 2005?
Your answer should be very brief. 1.38. What is the ratio of the Imports(as % of merchandise exports) in Burkina Faso in 2003 to that in 2005?
Your answer should be compact. 1.04. What is the ratio of the Imports(as % of merchandise exports) in Moldova in 2003 to that in 2005?
Your response must be concise. 1.17. What is the ratio of the Imports(as % of merchandise exports) in Middle East & North Africa (all income levels) in 2004 to that in 2005?
Offer a terse response. 1.17. What is the ratio of the Imports(as % of merchandise exports) of Bangladesh in 2004 to that in 2005?
Make the answer very short. 1.12. What is the ratio of the Imports(as % of merchandise exports) of Burkina Faso in 2004 to that in 2005?
Your answer should be very brief. 0.96. What is the ratio of the Imports(as % of merchandise exports) in Moldova in 2004 to that in 2005?
Provide a succinct answer. 1. What is the difference between the highest and the second highest Imports(as % of merchandise exports) of Middle East & North Africa (all income levels)?
Your response must be concise. 0.89. What is the difference between the highest and the second highest Imports(as % of merchandise exports) in Bangladesh?
Offer a terse response. 1.8. What is the difference between the highest and the second highest Imports(as % of merchandise exports) of Burkina Faso?
Offer a very short reply. 0.6. What is the difference between the highest and the second highest Imports(as % of merchandise exports) of Moldova?
Keep it short and to the point. 0.8. What is the difference between the highest and the lowest Imports(as % of merchandise exports) of Middle East & North Africa (all income levels)?
Offer a very short reply. 3.6. What is the difference between the highest and the lowest Imports(as % of merchandise exports) in Bangladesh?
Make the answer very short. 5.29. What is the difference between the highest and the lowest Imports(as % of merchandise exports) in Burkina Faso?
Give a very brief answer. 9.29. What is the difference between the highest and the lowest Imports(as % of merchandise exports) of Moldova?
Your answer should be very brief. 2.8. 